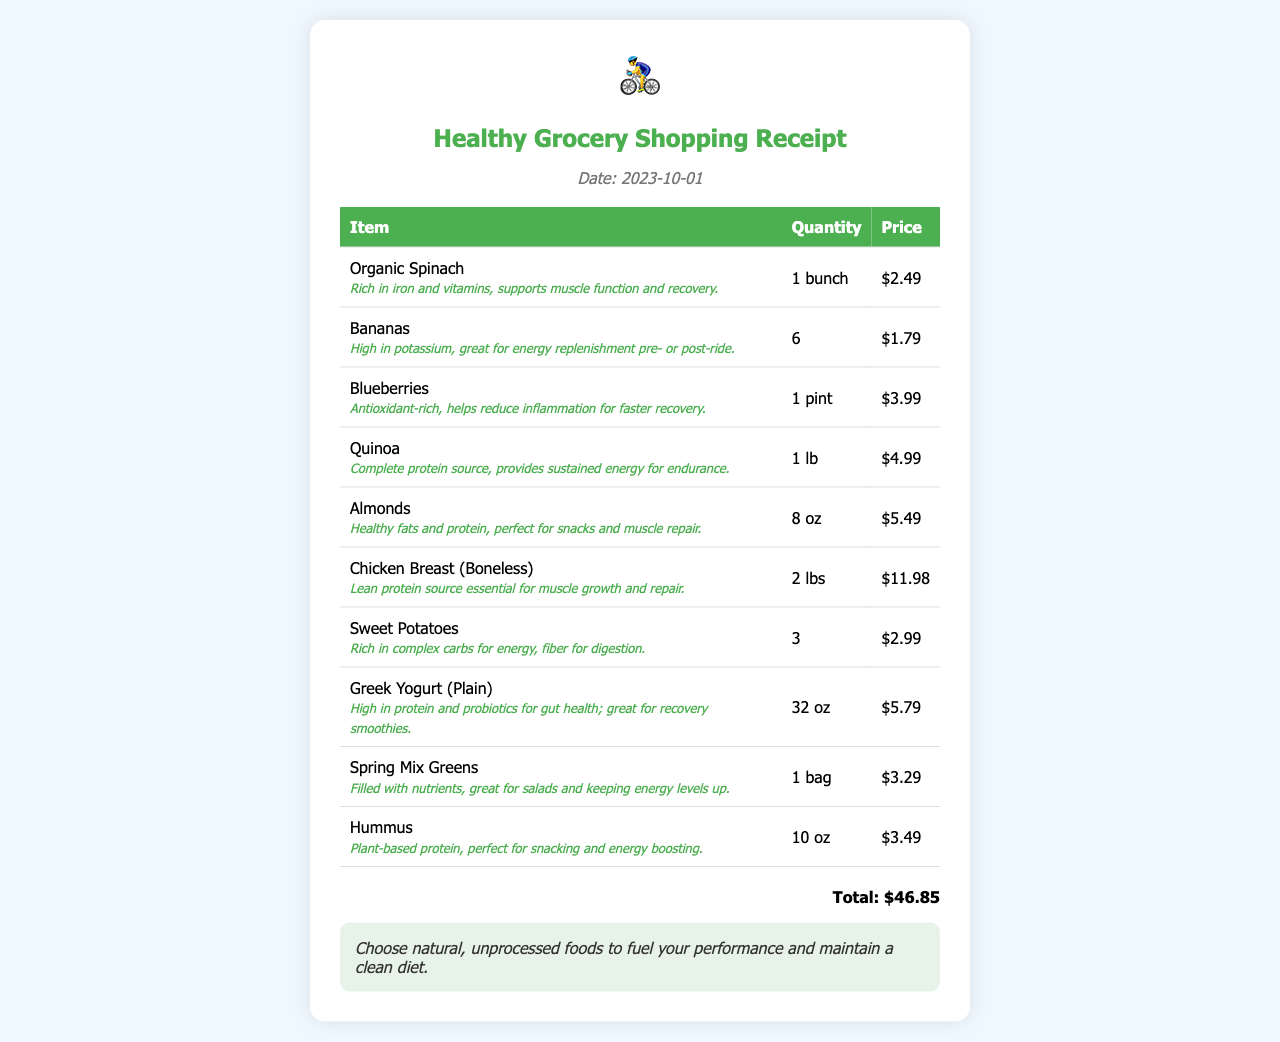What is the date of the receipt? The date of the receipt is listed in the document as 2023-10-01.
Answer: 2023-10-01 What item is high in potassium? The document specifies that Bananas are high in potassium.
Answer: Bananas How many pounds of chicken breast were purchased? The receipt shows that 2 lbs of Chicken Breast (Boneless) were purchased.
Answer: 2 lbs What is the price of Greek Yogurt? The price listed for Greek Yogurt (Plain) in the document is $5.79.
Answer: $5.79 Which item is a complete protein source? The document indicates that Quinoa is a complete protein source.
Answer: Quinoa What is the total amount spent on groceries? The total amount spent on groceries is displayed at the bottom of the receipt, which is $46.85.
Answer: $46.85 How many ounces of almonds were bought? The receipt confirms that 8 oz of Almonds were purchased.
Answer: 8 oz What benefits do blueberries provide? The document mentions that blueberries are antioxidant-rich and help reduce inflammation for faster recovery.
Answer: Antioxidant-rich, helps reduce inflammation What type of food does the note recommend? The note at the bottom of the receipt suggests choosing natural, unprocessed foods.
Answer: Natural, unprocessed foods 